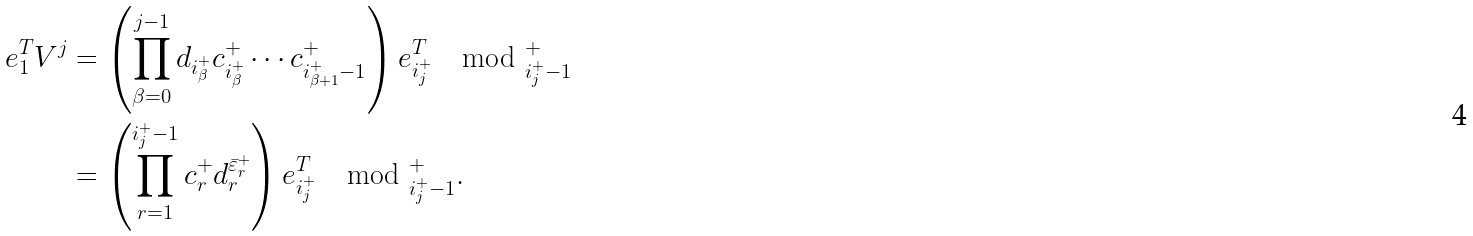Convert formula to latex. <formula><loc_0><loc_0><loc_500><loc_500>e _ { 1 } ^ { T } V ^ { j } & = \left ( \prod _ { \beta = 0 } ^ { j - 1 } d _ { i ^ { + } _ { \beta } } c ^ { + } _ { i ^ { + } _ { \beta } } \cdots c ^ { + } _ { i ^ { + } _ { \beta + 1 } - 1 } \right ) e _ { i ^ { + } _ { j } } ^ { T } \mod \L ^ { + } _ { i ^ { + } _ { j } - 1 } \\ & = \left ( \prod _ { r = 1 } ^ { i ^ { + } _ { j } - 1 } c ^ { + } _ { r } d ^ { \bar { \varepsilon } _ { r } ^ { + } } _ { r } \right ) e ^ { T } _ { i ^ { + } _ { j } } \mod \L ^ { + } _ { i ^ { + } _ { j } - 1 } .</formula> 